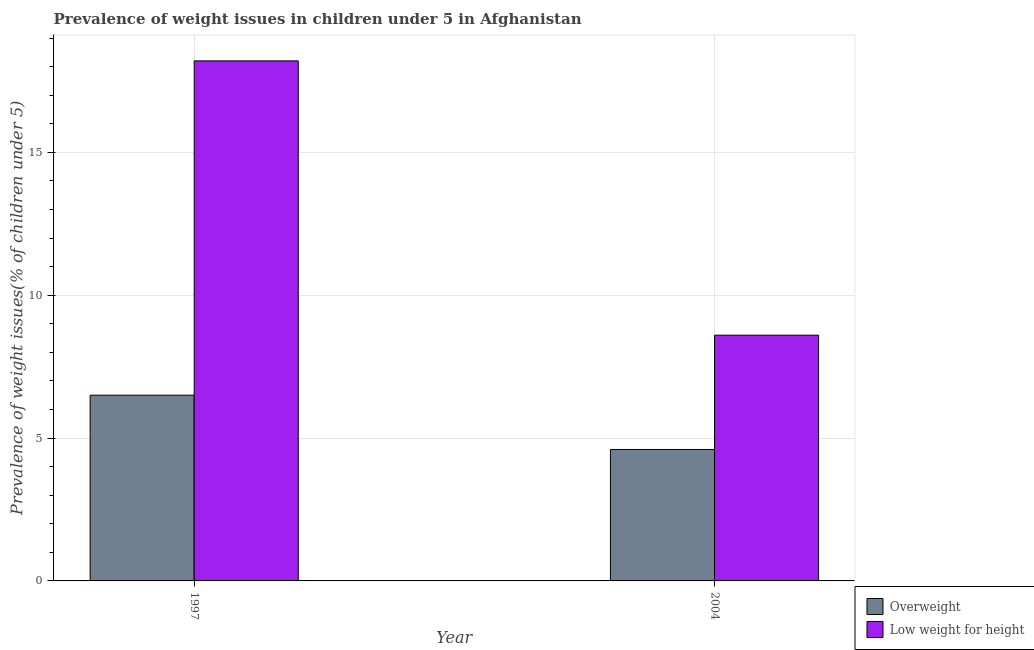How many different coloured bars are there?
Offer a very short reply. 2. How many bars are there on the 1st tick from the right?
Your response must be concise. 2. What is the label of the 2nd group of bars from the left?
Your answer should be very brief. 2004. In how many cases, is the number of bars for a given year not equal to the number of legend labels?
Make the answer very short. 0. What is the percentage of underweight children in 2004?
Offer a very short reply. 8.6. Across all years, what is the maximum percentage of overweight children?
Your answer should be compact. 6.5. Across all years, what is the minimum percentage of overweight children?
Provide a succinct answer. 4.6. What is the total percentage of underweight children in the graph?
Provide a succinct answer. 26.8. What is the difference between the percentage of overweight children in 1997 and that in 2004?
Provide a succinct answer. 1.9. What is the difference between the percentage of underweight children in 1997 and the percentage of overweight children in 2004?
Provide a short and direct response. 9.6. What is the average percentage of underweight children per year?
Offer a terse response. 13.4. In the year 2004, what is the difference between the percentage of underweight children and percentage of overweight children?
Provide a succinct answer. 0. In how many years, is the percentage of overweight children greater than 7 %?
Give a very brief answer. 0. What is the ratio of the percentage of underweight children in 1997 to that in 2004?
Your answer should be compact. 2.12. In how many years, is the percentage of underweight children greater than the average percentage of underweight children taken over all years?
Provide a succinct answer. 1. What does the 2nd bar from the left in 2004 represents?
Ensure brevity in your answer.  Low weight for height. What does the 2nd bar from the right in 2004 represents?
Make the answer very short. Overweight. What is the difference between two consecutive major ticks on the Y-axis?
Make the answer very short. 5. Are the values on the major ticks of Y-axis written in scientific E-notation?
Ensure brevity in your answer.  No. Does the graph contain grids?
Provide a succinct answer. Yes. How many legend labels are there?
Keep it short and to the point. 2. What is the title of the graph?
Provide a short and direct response. Prevalence of weight issues in children under 5 in Afghanistan. What is the label or title of the X-axis?
Your answer should be compact. Year. What is the label or title of the Y-axis?
Make the answer very short. Prevalence of weight issues(% of children under 5). What is the Prevalence of weight issues(% of children under 5) of Overweight in 1997?
Keep it short and to the point. 6.5. What is the Prevalence of weight issues(% of children under 5) in Low weight for height in 1997?
Your answer should be very brief. 18.2. What is the Prevalence of weight issues(% of children under 5) of Overweight in 2004?
Your answer should be very brief. 4.6. What is the Prevalence of weight issues(% of children under 5) in Low weight for height in 2004?
Your response must be concise. 8.6. Across all years, what is the maximum Prevalence of weight issues(% of children under 5) in Low weight for height?
Make the answer very short. 18.2. Across all years, what is the minimum Prevalence of weight issues(% of children under 5) of Overweight?
Offer a terse response. 4.6. Across all years, what is the minimum Prevalence of weight issues(% of children under 5) in Low weight for height?
Offer a terse response. 8.6. What is the total Prevalence of weight issues(% of children under 5) of Overweight in the graph?
Keep it short and to the point. 11.1. What is the total Prevalence of weight issues(% of children under 5) in Low weight for height in the graph?
Your answer should be very brief. 26.8. What is the difference between the Prevalence of weight issues(% of children under 5) of Overweight in 1997 and that in 2004?
Your response must be concise. 1.9. What is the difference between the Prevalence of weight issues(% of children under 5) of Overweight in 1997 and the Prevalence of weight issues(% of children under 5) of Low weight for height in 2004?
Provide a short and direct response. -2.1. What is the average Prevalence of weight issues(% of children under 5) in Overweight per year?
Make the answer very short. 5.55. In the year 2004, what is the difference between the Prevalence of weight issues(% of children under 5) of Overweight and Prevalence of weight issues(% of children under 5) of Low weight for height?
Keep it short and to the point. -4. What is the ratio of the Prevalence of weight issues(% of children under 5) in Overweight in 1997 to that in 2004?
Keep it short and to the point. 1.41. What is the ratio of the Prevalence of weight issues(% of children under 5) of Low weight for height in 1997 to that in 2004?
Provide a short and direct response. 2.12. What is the difference between the highest and the second highest Prevalence of weight issues(% of children under 5) in Overweight?
Ensure brevity in your answer.  1.9. What is the difference between the highest and the lowest Prevalence of weight issues(% of children under 5) in Overweight?
Your response must be concise. 1.9. What is the difference between the highest and the lowest Prevalence of weight issues(% of children under 5) of Low weight for height?
Your answer should be very brief. 9.6. 